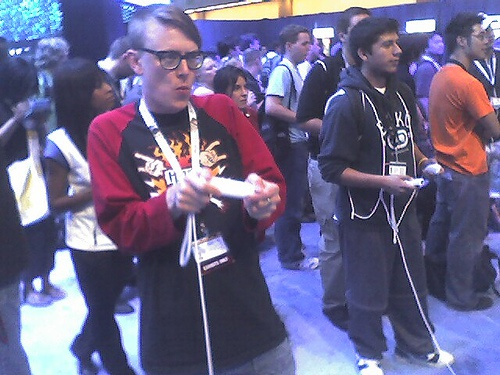Describe the objects in this image and their specific colors. I can see people in lavender, black, purple, and brown tones, people in lavender, navy, purple, black, and blue tones, people in lavender, navy, purple, white, and blue tones, people in lavender, purple, brown, navy, and salmon tones, and people in lavender, black, blue, and darkblue tones in this image. 